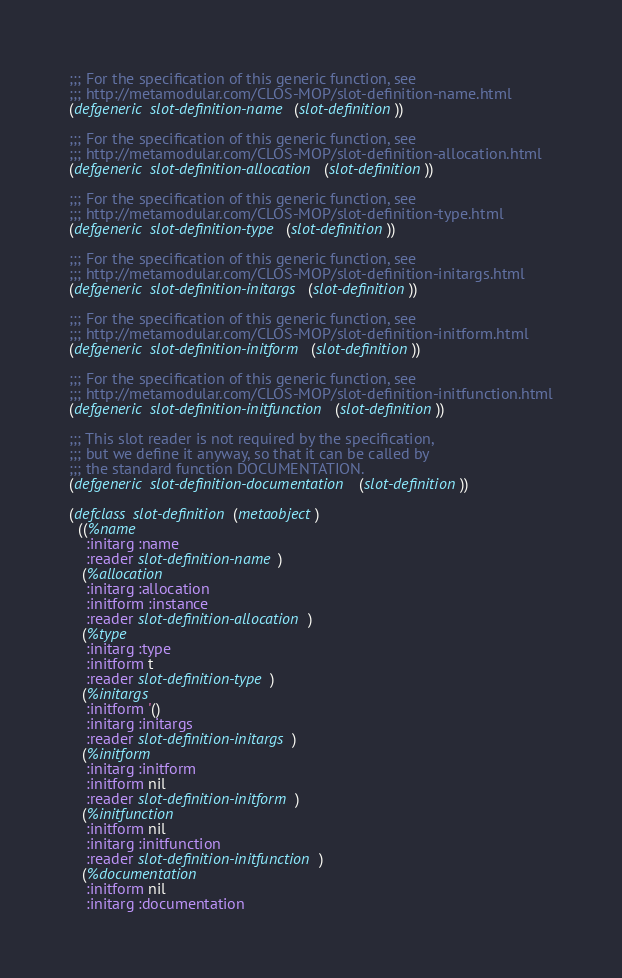<code> <loc_0><loc_0><loc_500><loc_500><_Lisp_>;;; For the specification of this generic function, see
;;; http://metamodular.com/CLOS-MOP/slot-definition-name.html
(defgeneric slot-definition-name (slot-definition))

;;; For the specification of this generic function, see
;;; http://metamodular.com/CLOS-MOP/slot-definition-allocation.html
(defgeneric slot-definition-allocation (slot-definition))

;;; For the specification of this generic function, see
;;; http://metamodular.com/CLOS-MOP/slot-definition-type.html
(defgeneric slot-definition-type (slot-definition))

;;; For the specification of this generic function, see
;;; http://metamodular.com/CLOS-MOP/slot-definition-initargs.html
(defgeneric slot-definition-initargs (slot-definition))

;;; For the specification of this generic function, see
;;; http://metamodular.com/CLOS-MOP/slot-definition-initform.html
(defgeneric slot-definition-initform (slot-definition))

;;; For the specification of this generic function, see
;;; http://metamodular.com/CLOS-MOP/slot-definition-initfunction.html
(defgeneric slot-definition-initfunction (slot-definition))

;;; This slot reader is not required by the specification,
;;; but we define it anyway, so that it can be called by 
;;; the standard function DOCUMENTATION.
(defgeneric slot-definition-documentation (slot-definition))

(defclass slot-definition (metaobject)
  ((%name 
    :initarg :name
    :reader slot-definition-name)
   (%allocation 
    :initarg :allocation
    :initform :instance
    :reader slot-definition-allocation)
   (%type 
    :initarg :type
    :initform t
    :reader slot-definition-type)
   (%initargs 
    :initform '()
    :initarg :initargs 
    :reader slot-definition-initargs)
   (%initform 
    :initarg :initform 
    :initform nil
    :reader slot-definition-initform)
   (%initfunction
    :initform nil
    :initarg :initfunction
    :reader slot-definition-initfunction)
   (%documentation
    :initform nil
    :initarg :documentation</code> 